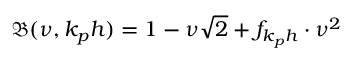Convert formula to latex. <formula><loc_0><loc_0><loc_500><loc_500>\mathfrak { B } ( \nu , k _ { p } h ) = 1 - \nu \sqrt { 2 } + f _ { k _ { p } h } \cdot \nu ^ { 2 }</formula> 